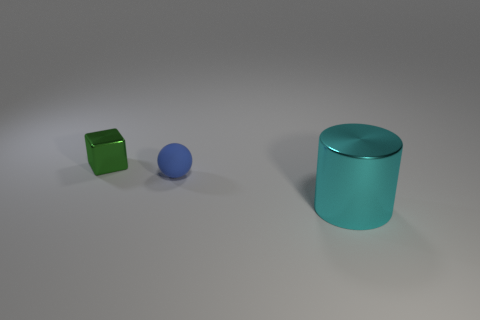Is there any other thing that has the same shape as the small blue matte thing?
Your response must be concise. No. How many other things are made of the same material as the cyan cylinder?
Ensure brevity in your answer.  1. There is a large metallic cylinder; is its color the same as the tiny thing in front of the small green shiny thing?
Provide a succinct answer. No. There is a tiny object in front of the tiny green block; what is its material?
Keep it short and to the point. Rubber. What color is the ball that is the same size as the metal cube?
Offer a terse response. Blue. How many tiny objects are either cyan metallic objects or blue matte things?
Provide a succinct answer. 1. Are there an equal number of cyan metallic things to the left of the small cube and green metal things behind the small blue matte thing?
Keep it short and to the point. No. How many metallic blocks have the same size as the cyan metallic thing?
Your answer should be compact. 0. What number of gray things are either tiny balls or cubes?
Your answer should be compact. 0. Is the number of balls that are behind the blue sphere the same as the number of tiny cyan cubes?
Provide a succinct answer. Yes. 